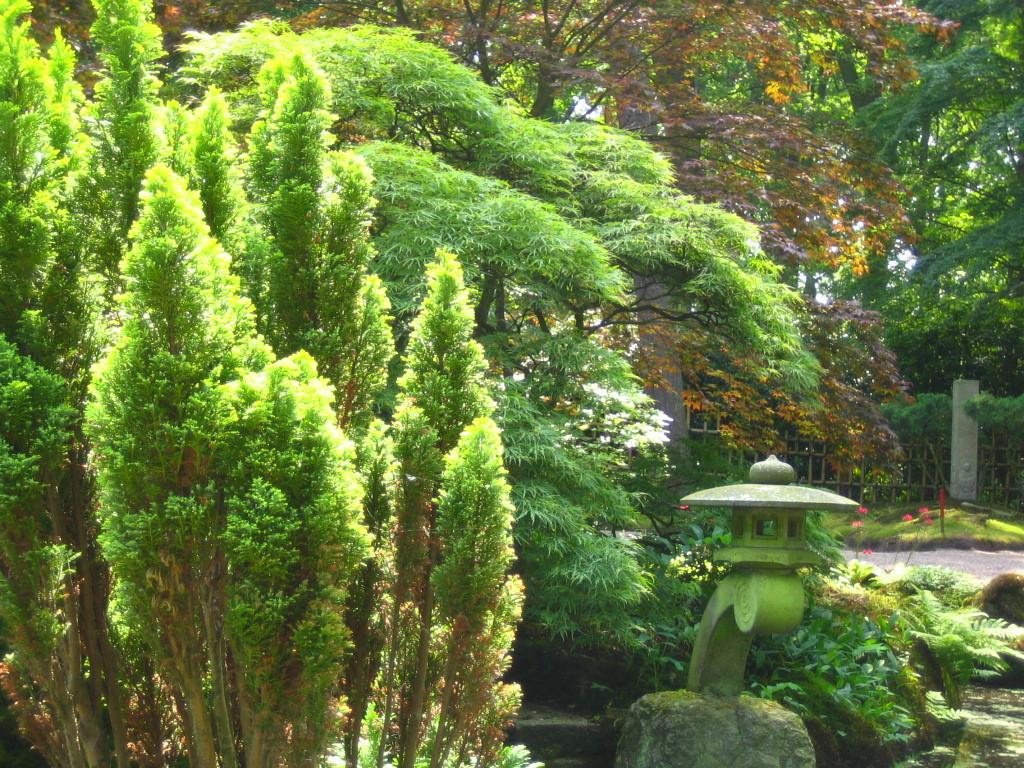What type of natural elements can be seen in the image? There are many trees in the image. What type of man-made object is present in the image? There is an object made with concrete in the image. What type of architectural feature can be seen in the image? There is a railing in the back of the image. What type of transportation infrastructure is present in the image? There is a road in the image. What type of spoon can be seen hanging from the tree in the image? There is no spoon present in the image; only trees, a concrete object, a railing, and a road can be seen. Is there a turkey visible in the image? No, there is no turkey present in the image. 